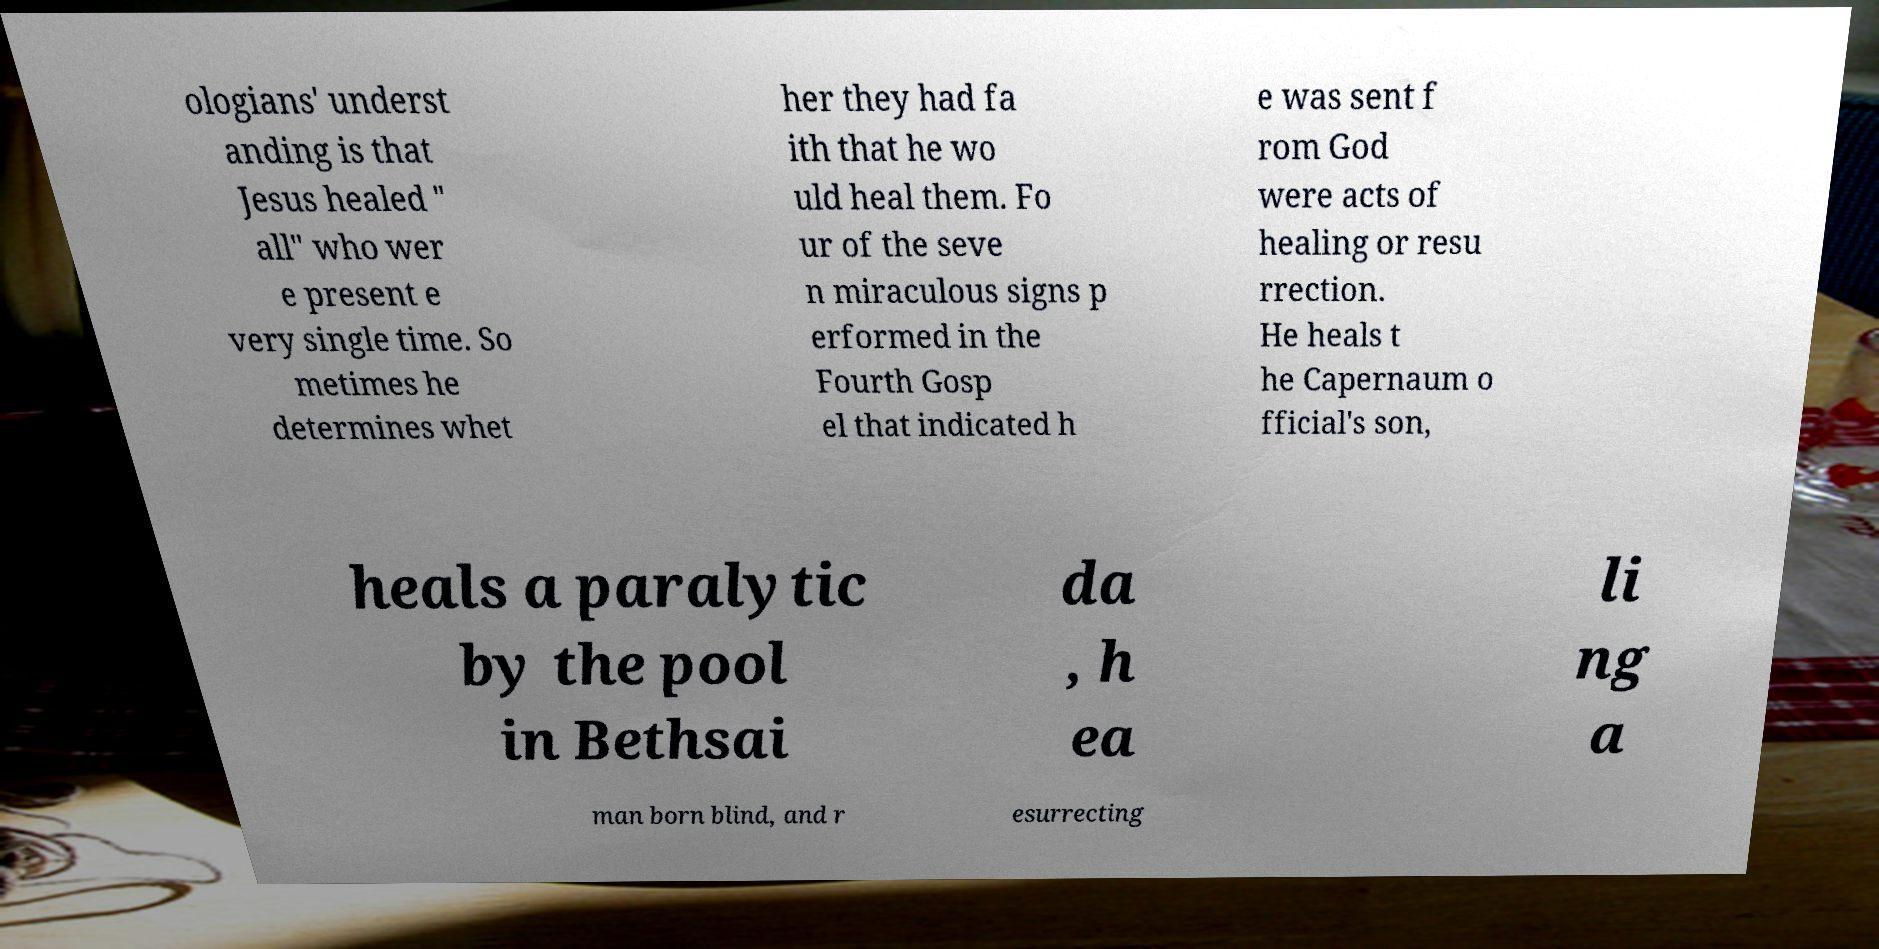Could you assist in decoding the text presented in this image and type it out clearly? ologians' underst anding is that Jesus healed " all" who wer e present e very single time. So metimes he determines whet her they had fa ith that he wo uld heal them. Fo ur of the seve n miraculous signs p erformed in the Fourth Gosp el that indicated h e was sent f rom God were acts of healing or resu rrection. He heals t he Capernaum o fficial's son, heals a paralytic by the pool in Bethsai da , h ea li ng a man born blind, and r esurrecting 